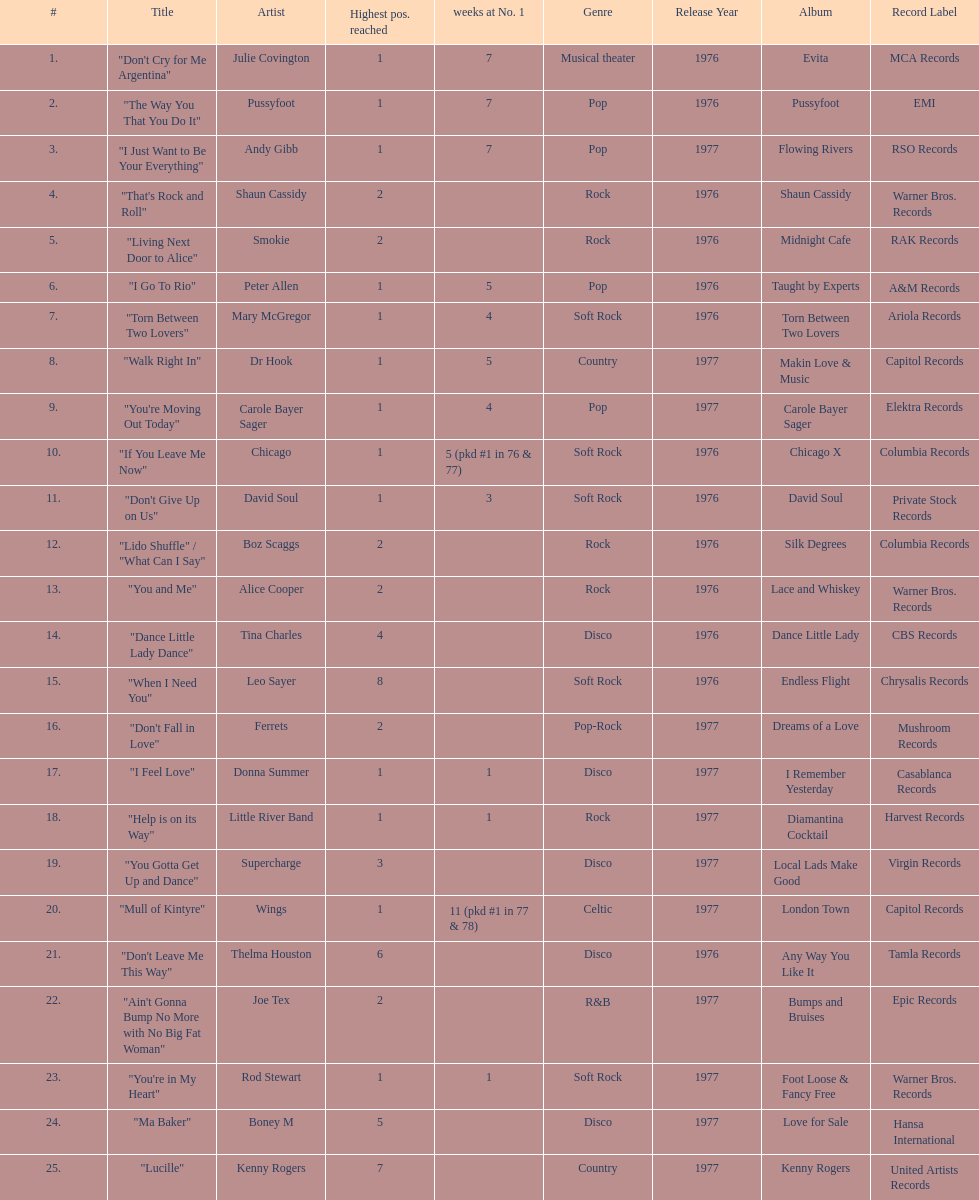What was the number of weeks that julie covington's single " don't cry for me argentinia," was at number 1 in 1977? 7. 